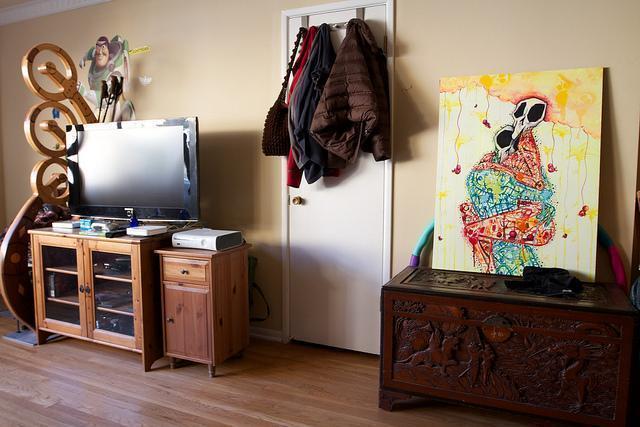What color is the coat jacket on the right side of the rack hung on the white door?
Make your selection from the four choices given to correctly answer the question.
Options: Brown, red, purple, black. Brown. 